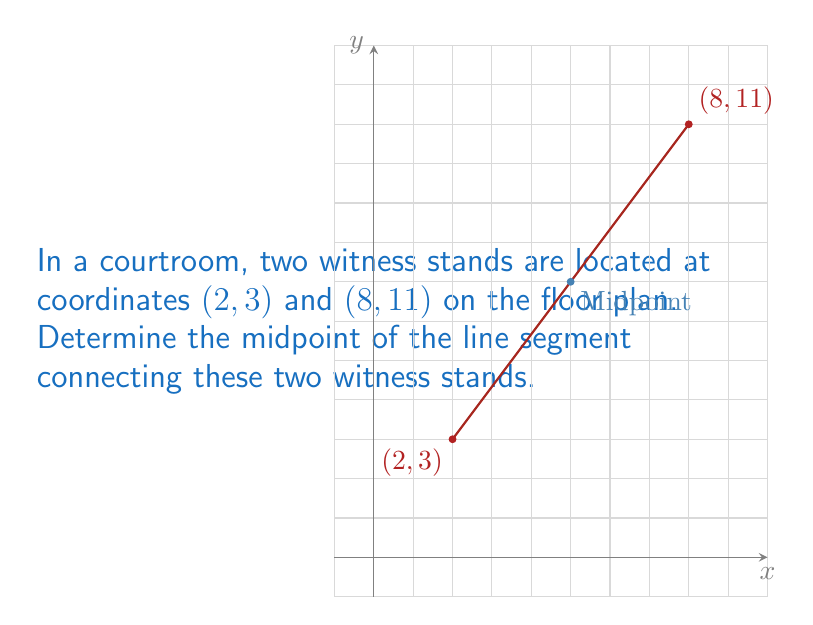Provide a solution to this math problem. To find the midpoint of a line segment connecting two points, we use the midpoint formula:

$$ \text{Midpoint} = \left(\frac{x_1 + x_2}{2}, \frac{y_1 + y_2}{2}\right) $$

Where $(x_1, y_1)$ and $(x_2, y_2)$ are the coordinates of the two endpoints.

Given:
- Witness stand 1: $(x_1, y_1) = (2, 3)$
- Witness stand 2: $(x_2, y_2) = (8, 11)$

Step 1: Calculate the x-coordinate of the midpoint:
$$ x_{\text{midpoint}} = \frac{x_1 + x_2}{2} = \frac{2 + 8}{2} = \frac{10}{2} = 5 $$

Step 2: Calculate the y-coordinate of the midpoint:
$$ y_{\text{midpoint}} = \frac{y_1 + y_2}{2} = \frac{3 + 11}{2} = \frac{14}{2} = 7 $$

Step 3: Combine the results to get the midpoint coordinates:
$$ \text{Midpoint} = (5, 7) $$
Answer: (5, 7) 